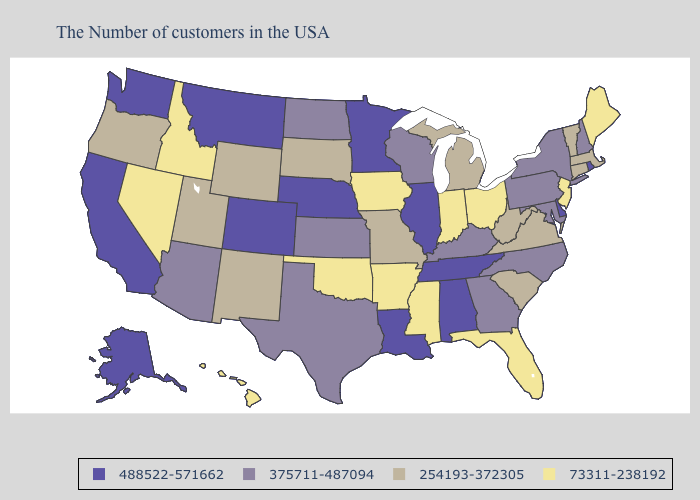Name the states that have a value in the range 73311-238192?
Keep it brief. Maine, New Jersey, Ohio, Florida, Indiana, Mississippi, Arkansas, Iowa, Oklahoma, Idaho, Nevada, Hawaii. What is the lowest value in states that border Ohio?
Keep it brief. 73311-238192. Name the states that have a value in the range 73311-238192?
Answer briefly. Maine, New Jersey, Ohio, Florida, Indiana, Mississippi, Arkansas, Iowa, Oklahoma, Idaho, Nevada, Hawaii. Does Wyoming have the lowest value in the USA?
Answer briefly. No. Name the states that have a value in the range 488522-571662?
Give a very brief answer. Rhode Island, Delaware, Alabama, Tennessee, Illinois, Louisiana, Minnesota, Nebraska, Colorado, Montana, California, Washington, Alaska. Which states hav the highest value in the South?
Quick response, please. Delaware, Alabama, Tennessee, Louisiana. What is the value of North Carolina?
Be succinct. 375711-487094. Does Massachusetts have the lowest value in the Northeast?
Write a very short answer. No. What is the value of Washington?
Write a very short answer. 488522-571662. What is the value of Montana?
Concise answer only. 488522-571662. Name the states that have a value in the range 73311-238192?
Give a very brief answer. Maine, New Jersey, Ohio, Florida, Indiana, Mississippi, Arkansas, Iowa, Oklahoma, Idaho, Nevada, Hawaii. Name the states that have a value in the range 254193-372305?
Give a very brief answer. Massachusetts, Vermont, Connecticut, Virginia, South Carolina, West Virginia, Michigan, Missouri, South Dakota, Wyoming, New Mexico, Utah, Oregon. Which states hav the highest value in the MidWest?
Give a very brief answer. Illinois, Minnesota, Nebraska. Does the map have missing data?
Answer briefly. No. Does the map have missing data?
Concise answer only. No. 